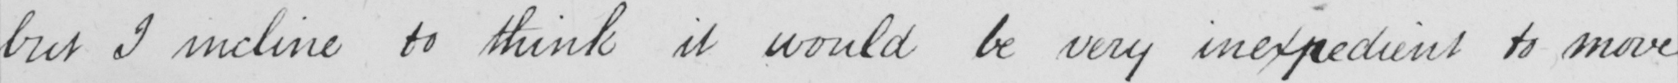Can you tell me what this handwritten text says? but I incline to think it would be very inexpedient to move 